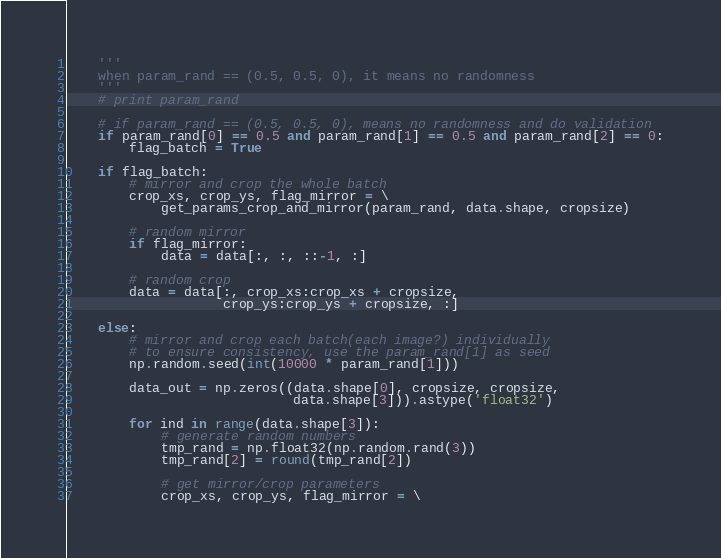Convert code to text. <code><loc_0><loc_0><loc_500><loc_500><_Python_>    '''
    when param_rand == (0.5, 0.5, 0), it means no randomness
    '''
    # print param_rand

    # if param_rand == (0.5, 0.5, 0), means no randomness and do validation
    if param_rand[0] == 0.5 and param_rand[1] == 0.5 and param_rand[2] == 0:
        flag_batch = True

    if flag_batch:
        # mirror and crop the whole batch
        crop_xs, crop_ys, flag_mirror = \
            get_params_crop_and_mirror(param_rand, data.shape, cropsize)

        # random mirror
        if flag_mirror:
            data = data[:, :, ::-1, :]

        # random crop
        data = data[:, crop_xs:crop_xs + cropsize,
                    crop_ys:crop_ys + cropsize, :]

    else:
        # mirror and crop each batch(each image?) individually
        # to ensure consistency, use the param_rand[1] as seed
        np.random.seed(int(10000 * param_rand[1]))

        data_out = np.zeros((data.shape[0], cropsize, cropsize,
                             data.shape[3])).astype('float32')

        for ind in range(data.shape[3]):
            # generate random numbers
            tmp_rand = np.float32(np.random.rand(3))
            tmp_rand[2] = round(tmp_rand[2])

            # get mirror/crop parameters
            crop_xs, crop_ys, flag_mirror = \</code> 